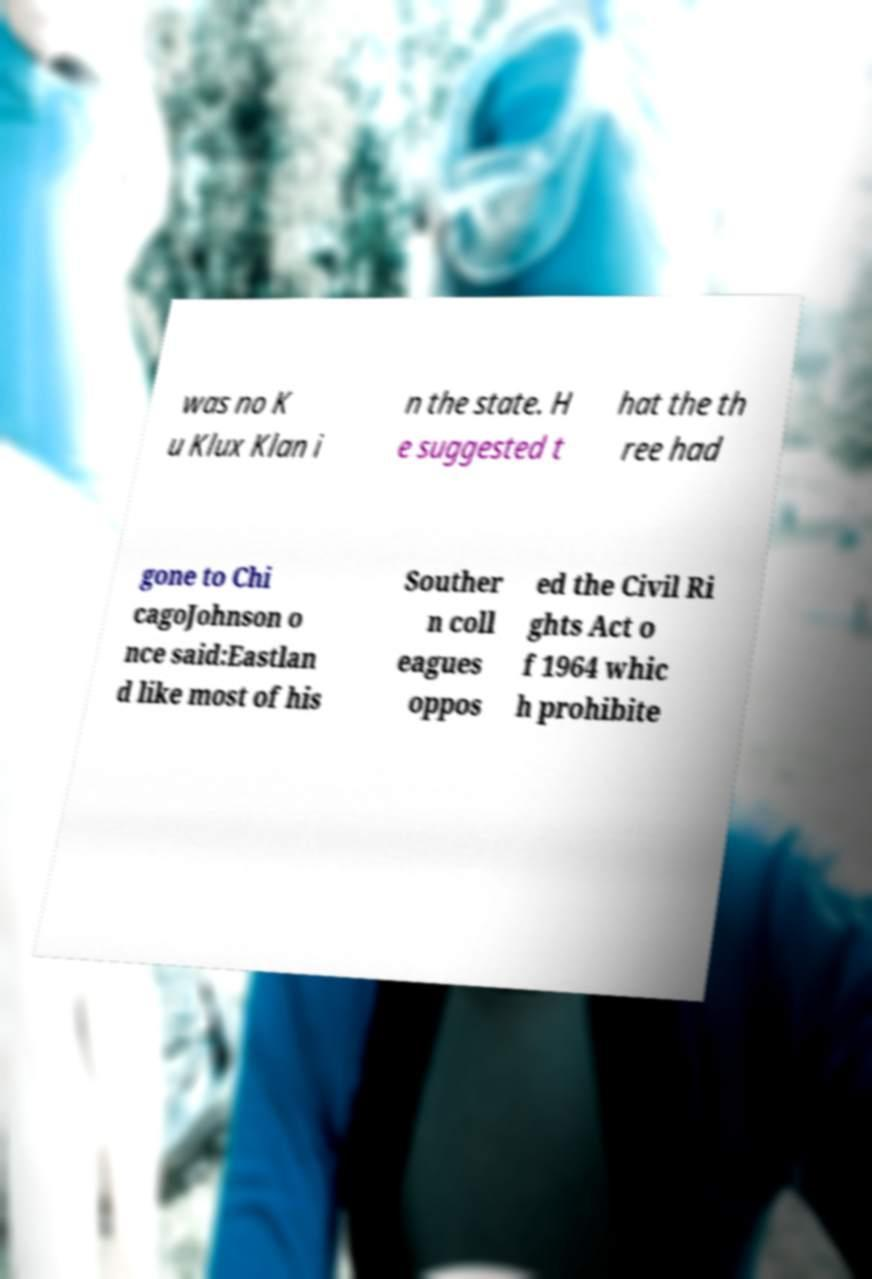Can you accurately transcribe the text from the provided image for me? was no K u Klux Klan i n the state. H e suggested t hat the th ree had gone to Chi cagoJohnson o nce said:Eastlan d like most of his Souther n coll eagues oppos ed the Civil Ri ghts Act o f 1964 whic h prohibite 